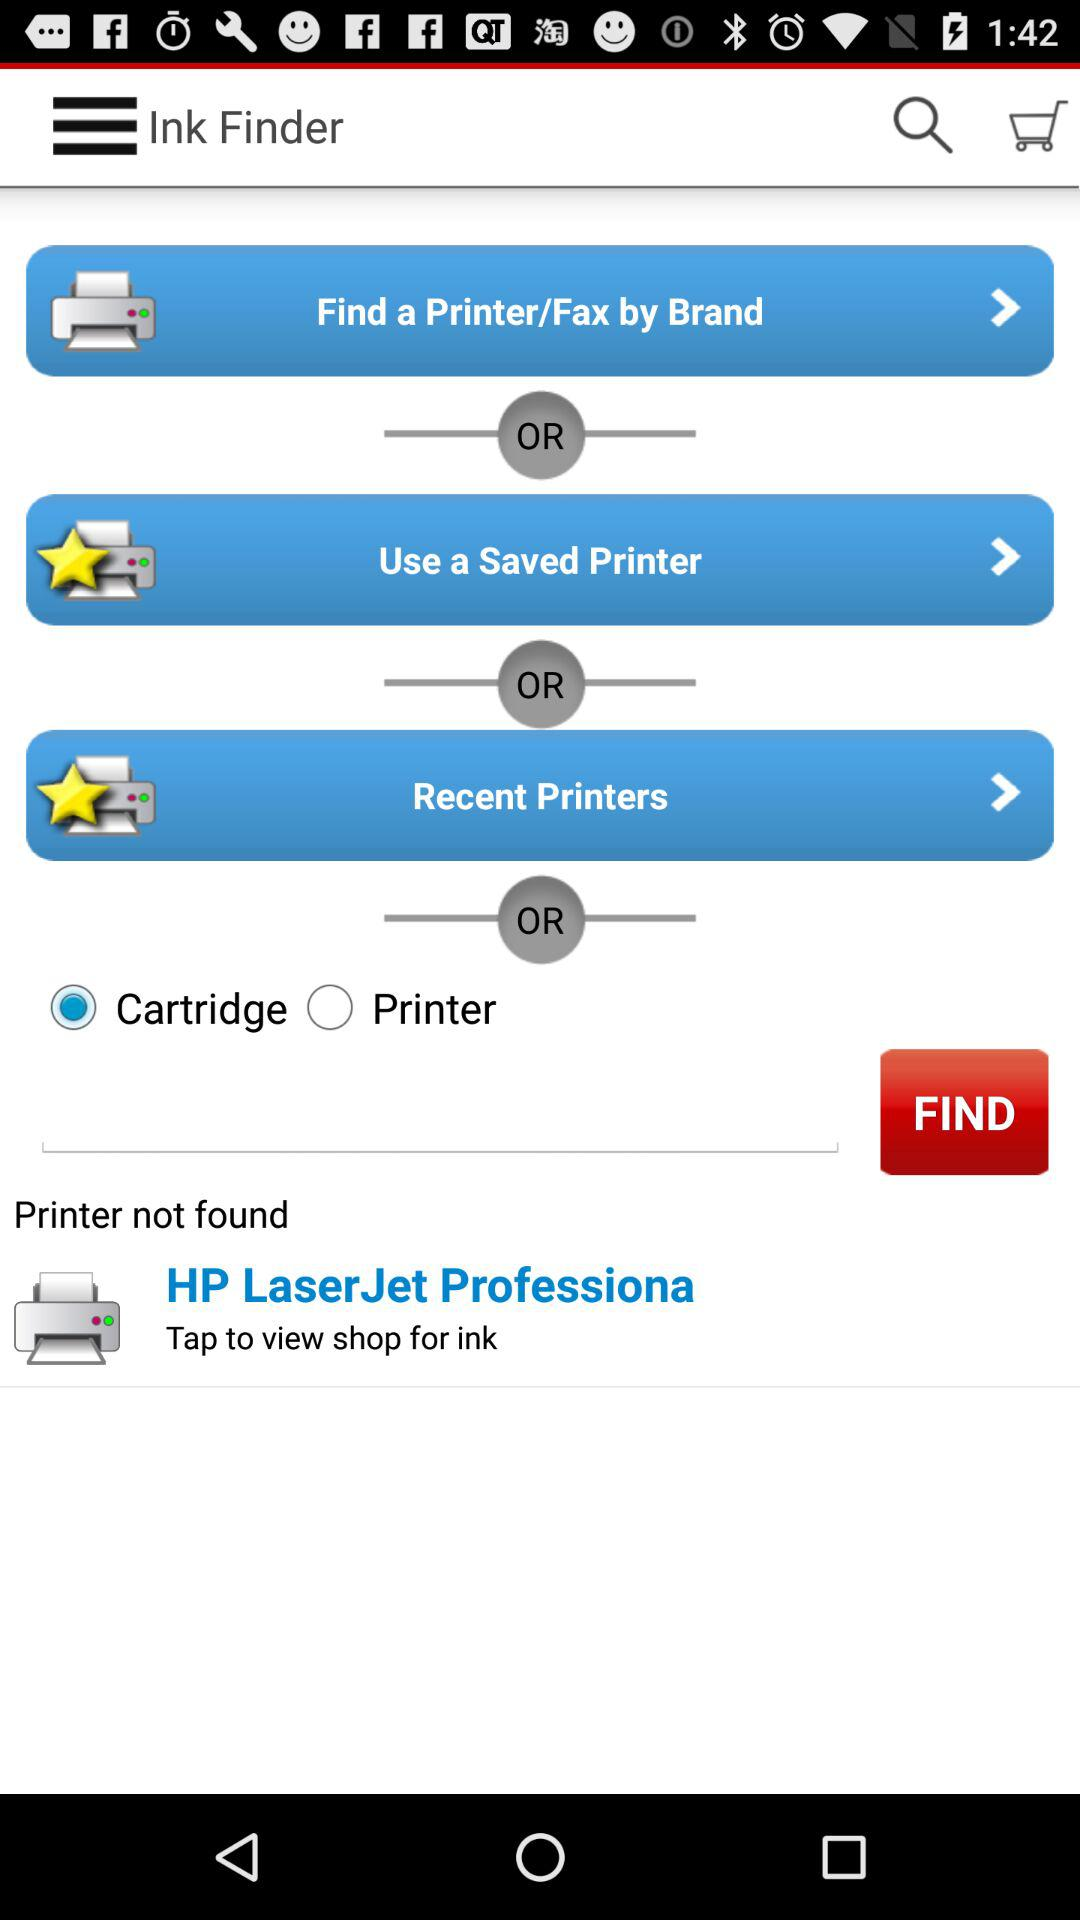Which option has been chosen? The chosen option is Cartridge. 